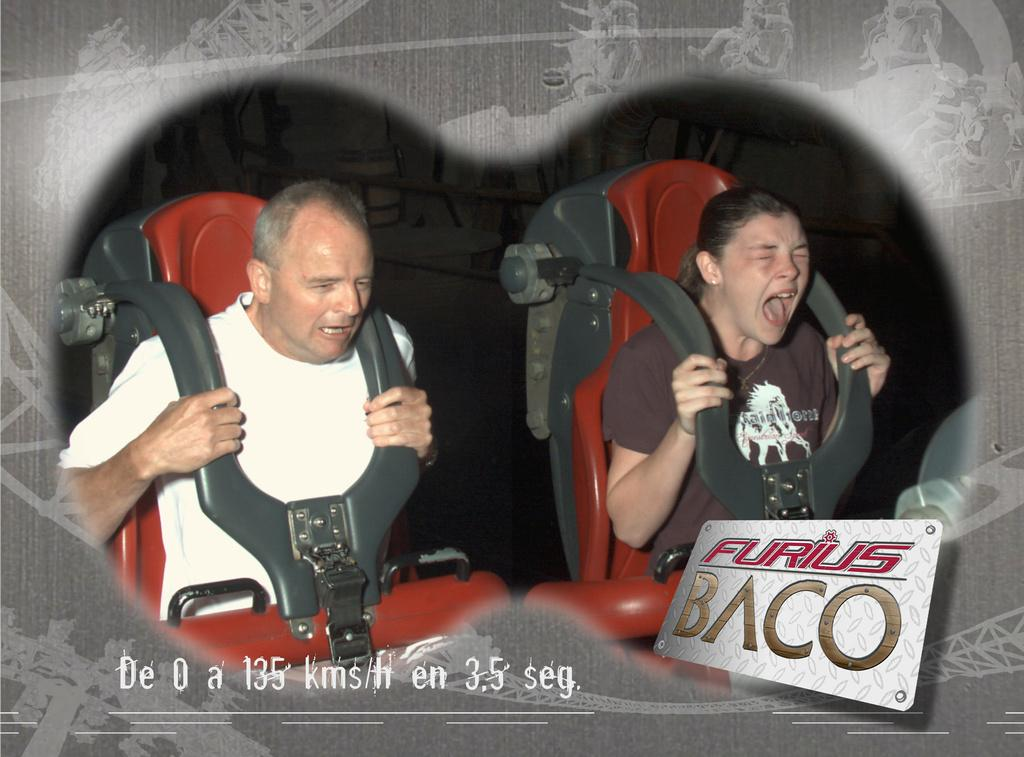What types of people are in the image? There are women and men in the image. What are the women and men doing in the image? They are sitting on seats and holding rods. What is the position of their mouths in the image? Their mouths are open. What can be found at the bottom of the image? There is text at the bottom of the image. What type of stew is being served to the rat in the image? There is no rat or stew present in the image. 